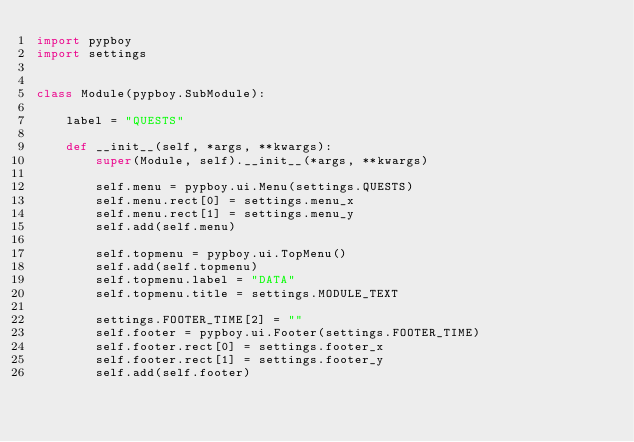Convert code to text. <code><loc_0><loc_0><loc_500><loc_500><_Python_>import pypboy
import settings


class Module(pypboy.SubModule):

    label = "QUESTS"

    def __init__(self, *args, **kwargs):
        super(Module, self).__init__(*args, **kwargs)

        self.menu = pypboy.ui.Menu(settings.QUESTS)
        self.menu.rect[0] = settings.menu_x
        self.menu.rect[1] = settings.menu_y
        self.add(self.menu)

        self.topmenu = pypboy.ui.TopMenu()
        self.add(self.topmenu)
        self.topmenu.label = "DATA"
        self.topmenu.title = settings.MODULE_TEXT

        settings.FOOTER_TIME[2] = ""
        self.footer = pypboy.ui.Footer(settings.FOOTER_TIME)
        self.footer.rect[0] = settings.footer_x
        self.footer.rect[1] = settings.footer_y
        self.add(self.footer)
</code> 